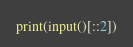Convert code to text. <code><loc_0><loc_0><loc_500><loc_500><_Python_>print(input()[::2])</code> 